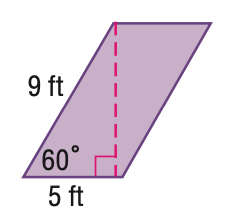Answer the mathemtical geometry problem and directly provide the correct option letter.
Question: Find the area of the parallelogram. Round to the nearest tenth if necessary.
Choices: A: 25 B: 39.0 C: 43.3 D: 45 B 